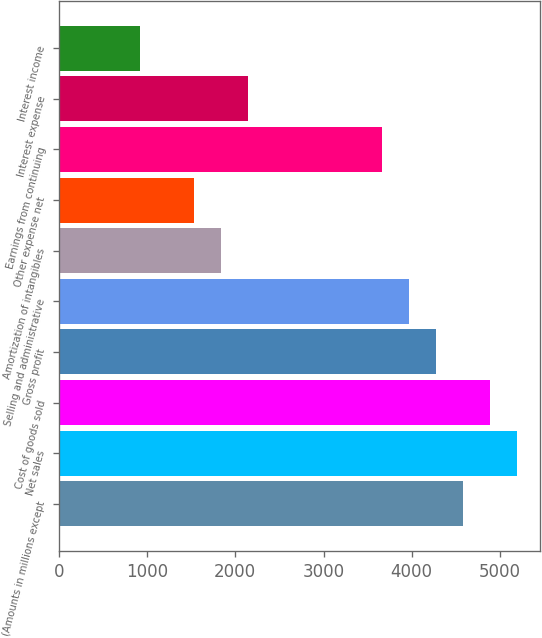Convert chart to OTSL. <chart><loc_0><loc_0><loc_500><loc_500><bar_chart><fcel>(Amounts in millions except<fcel>Net sales<fcel>Cost of goods sold<fcel>Gross profit<fcel>Selling and administrative<fcel>Amortization of intangibles<fcel>Other expense net<fcel>Earnings from continuing<fcel>Interest expense<fcel>Interest income<nl><fcel>4582.69<fcel>5193.71<fcel>4888.2<fcel>4277.18<fcel>3971.67<fcel>1833.1<fcel>1527.59<fcel>3666.16<fcel>2138.61<fcel>916.57<nl></chart> 